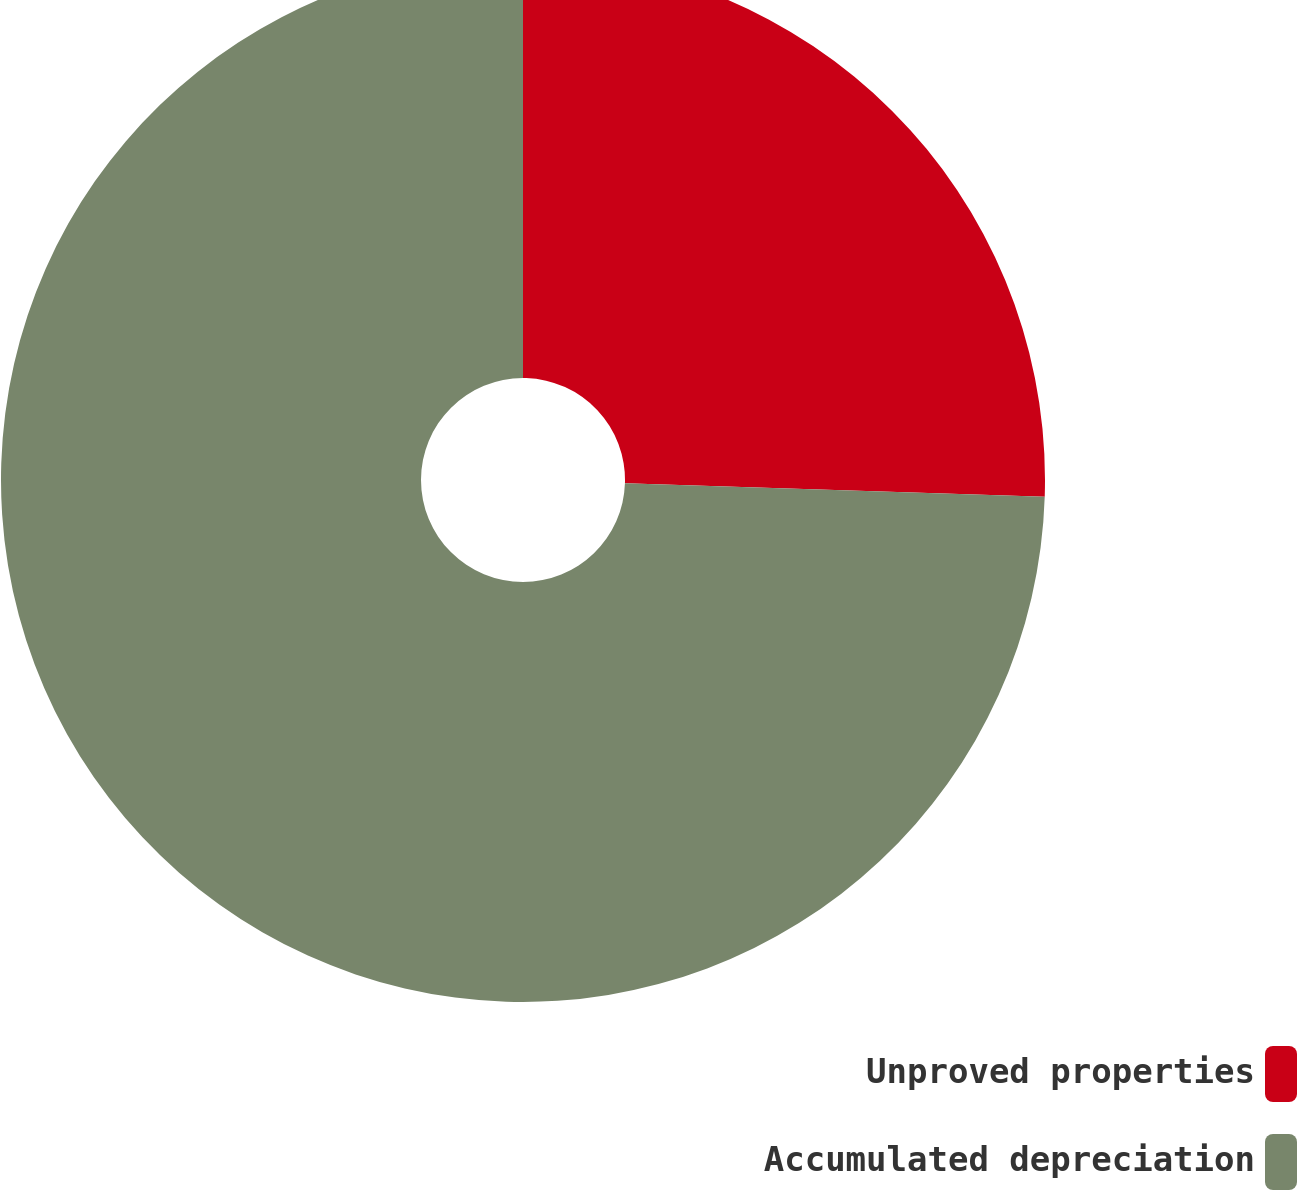Convert chart to OTSL. <chart><loc_0><loc_0><loc_500><loc_500><pie_chart><fcel>Unproved properties<fcel>Accumulated depreciation<nl><fcel>25.51%<fcel>74.49%<nl></chart> 